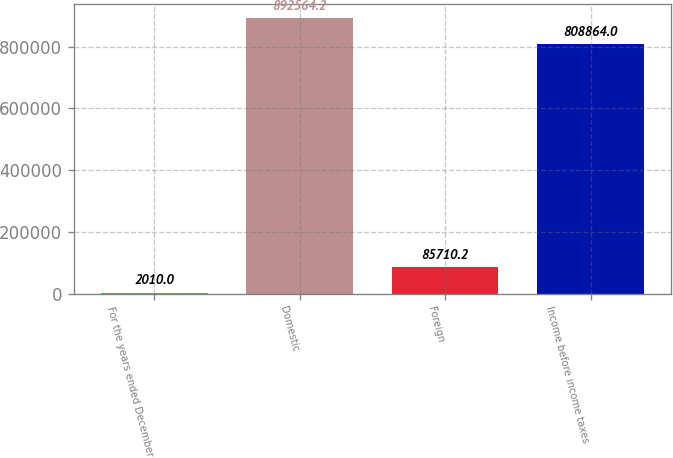Convert chart. <chart><loc_0><loc_0><loc_500><loc_500><bar_chart><fcel>For the years ended December<fcel>Domestic<fcel>Foreign<fcel>Income before income taxes<nl><fcel>2010<fcel>892564<fcel>85710.2<fcel>808864<nl></chart> 